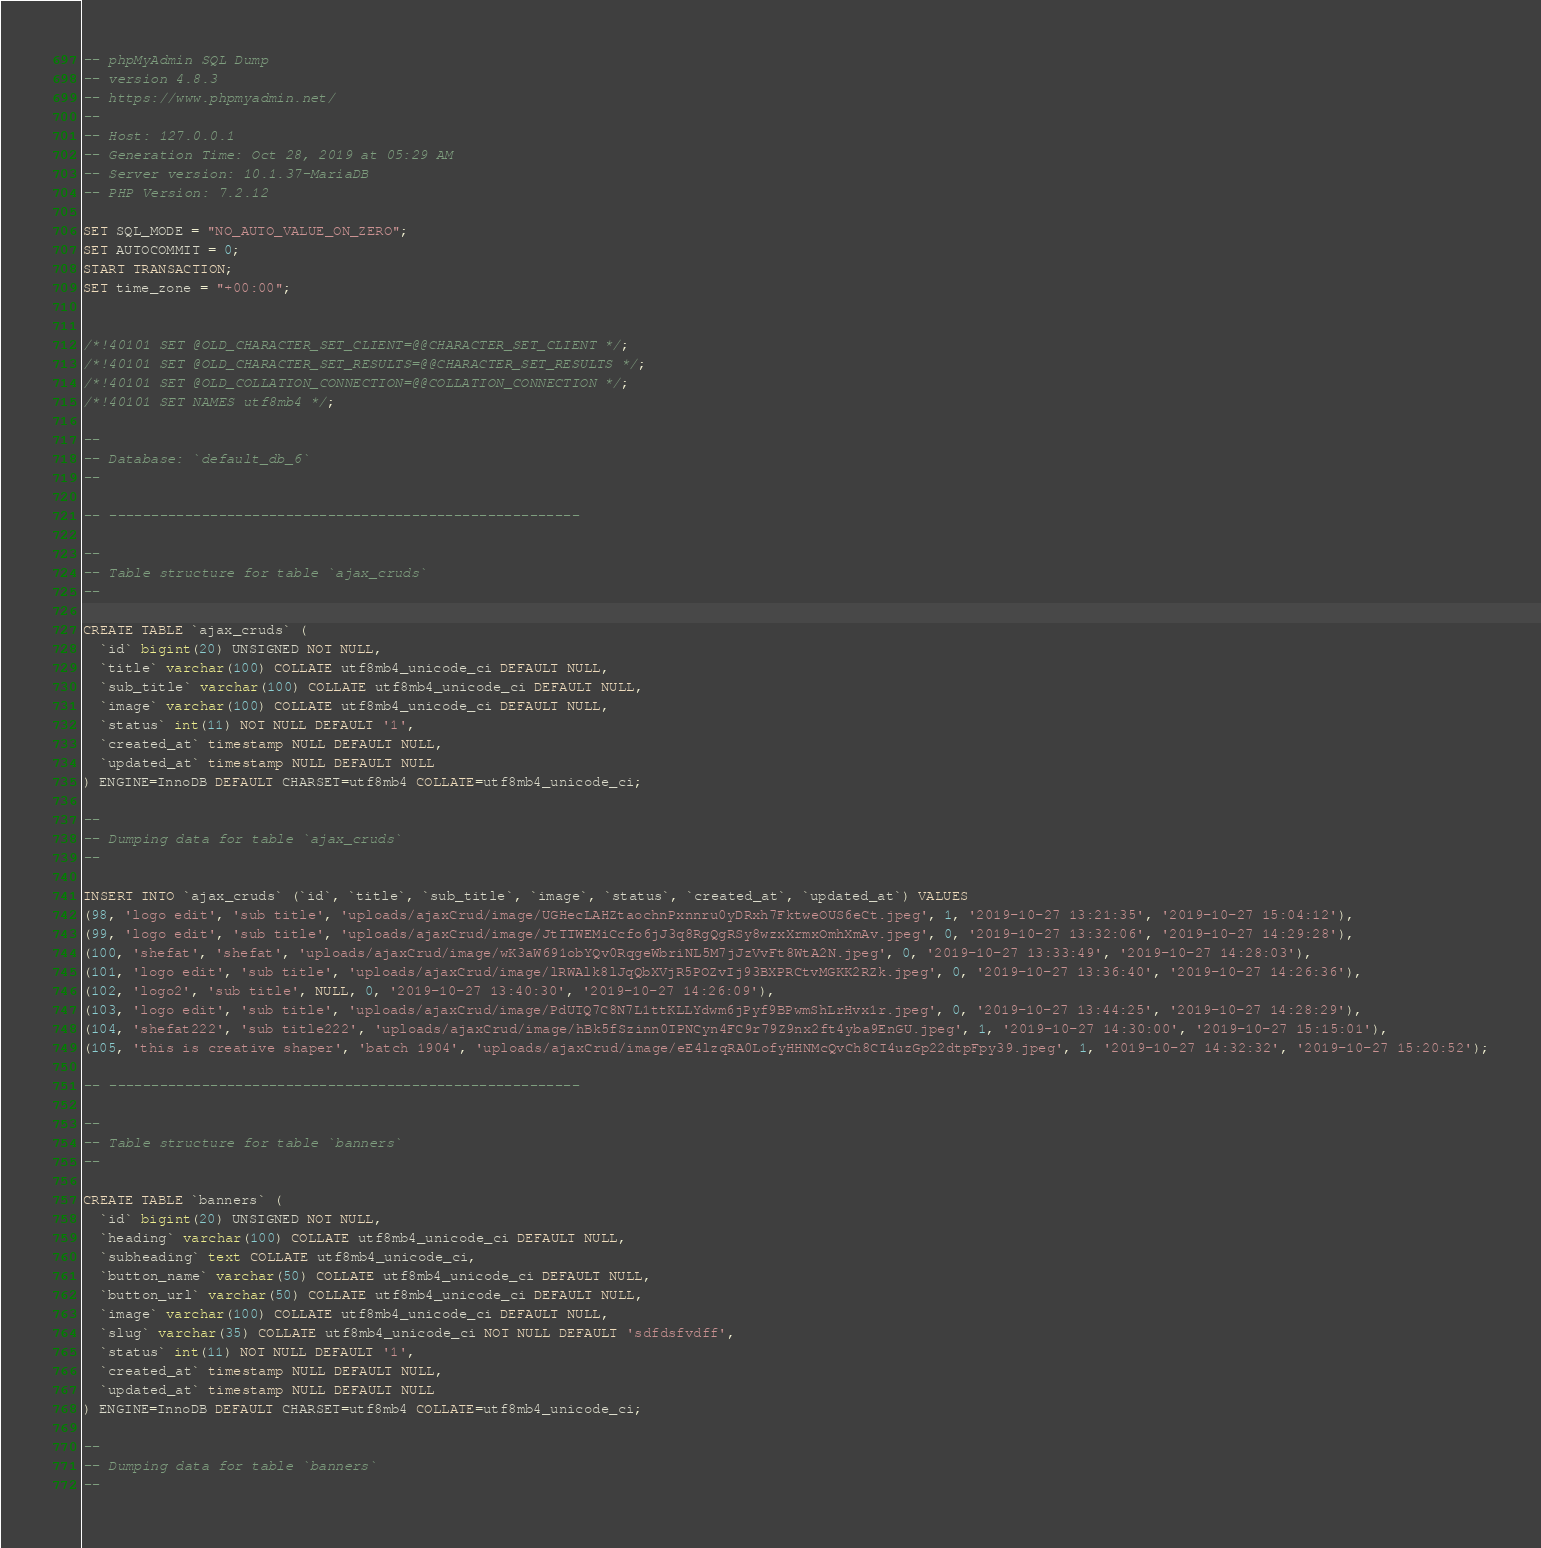Convert code to text. <code><loc_0><loc_0><loc_500><loc_500><_SQL_>-- phpMyAdmin SQL Dump
-- version 4.8.3
-- https://www.phpmyadmin.net/
--
-- Host: 127.0.0.1
-- Generation Time: Oct 28, 2019 at 05:29 AM
-- Server version: 10.1.37-MariaDB
-- PHP Version: 7.2.12

SET SQL_MODE = "NO_AUTO_VALUE_ON_ZERO";
SET AUTOCOMMIT = 0;
START TRANSACTION;
SET time_zone = "+00:00";


/*!40101 SET @OLD_CHARACTER_SET_CLIENT=@@CHARACTER_SET_CLIENT */;
/*!40101 SET @OLD_CHARACTER_SET_RESULTS=@@CHARACTER_SET_RESULTS */;
/*!40101 SET @OLD_COLLATION_CONNECTION=@@COLLATION_CONNECTION */;
/*!40101 SET NAMES utf8mb4 */;

--
-- Database: `default_db_6`
--

-- --------------------------------------------------------

--
-- Table structure for table `ajax_cruds`
--

CREATE TABLE `ajax_cruds` (
  `id` bigint(20) UNSIGNED NOT NULL,
  `title` varchar(100) COLLATE utf8mb4_unicode_ci DEFAULT NULL,
  `sub_title` varchar(100) COLLATE utf8mb4_unicode_ci DEFAULT NULL,
  `image` varchar(100) COLLATE utf8mb4_unicode_ci DEFAULT NULL,
  `status` int(11) NOT NULL DEFAULT '1',
  `created_at` timestamp NULL DEFAULT NULL,
  `updated_at` timestamp NULL DEFAULT NULL
) ENGINE=InnoDB DEFAULT CHARSET=utf8mb4 COLLATE=utf8mb4_unicode_ci;

--
-- Dumping data for table `ajax_cruds`
--

INSERT INTO `ajax_cruds` (`id`, `title`, `sub_title`, `image`, `status`, `created_at`, `updated_at`) VALUES
(98, 'logo edit', 'sub title', 'uploads/ajaxCrud/image/UGHecLAHZtaochnPxnnru0yDRxh7FktweOUS6eCt.jpeg', 1, '2019-10-27 13:21:35', '2019-10-27 15:04:12'),
(99, 'logo edit', 'sub title', 'uploads/ajaxCrud/image/JtTTWEMiCcfo6jJ3q8RgQgRSy8wzxXrmxOmhXmAv.jpeg', 0, '2019-10-27 13:32:06', '2019-10-27 14:29:28'),
(100, 'shefat', 'shefat', 'uploads/ajaxCrud/image/wK3aW691obYQv0RqgeWbriNL5M7jJzVvFt8WtA2N.jpeg', 0, '2019-10-27 13:33:49', '2019-10-27 14:28:03'),
(101, 'logo edit', 'sub title', 'uploads/ajaxCrud/image/lRWAlk8lJqQbXVjR5POZvIj93BXPRCtvMGKK2RZk.jpeg', 0, '2019-10-27 13:36:40', '2019-10-27 14:26:36'),
(102, 'logo2', 'sub title', NULL, 0, '2019-10-27 13:40:30', '2019-10-27 14:26:09'),
(103, 'logo edit', 'sub title', 'uploads/ajaxCrud/image/PdUTQ7C8N7L1ttKLLYdwm6jPyf9BPwmShLrHvx1r.jpeg', 0, '2019-10-27 13:44:25', '2019-10-27 14:28:29'),
(104, 'shefat222', 'sub title222', 'uploads/ajaxCrud/image/hBk5fSzinn0IPNCyn4FC9r79Z9nx2ft4yba9EnGU.jpeg', 1, '2019-10-27 14:30:00', '2019-10-27 15:15:01'),
(105, 'this is creative shaper', 'batch 1904', 'uploads/ajaxCrud/image/eE4lzqRA0LofyHHNMcQvCh8CI4uzGp22dtpFpy39.jpeg', 1, '2019-10-27 14:32:32', '2019-10-27 15:20:52');

-- --------------------------------------------------------

--
-- Table structure for table `banners`
--

CREATE TABLE `banners` (
  `id` bigint(20) UNSIGNED NOT NULL,
  `heading` varchar(100) COLLATE utf8mb4_unicode_ci DEFAULT NULL,
  `subheading` text COLLATE utf8mb4_unicode_ci,
  `button_name` varchar(50) COLLATE utf8mb4_unicode_ci DEFAULT NULL,
  `button_url` varchar(50) COLLATE utf8mb4_unicode_ci DEFAULT NULL,
  `image` varchar(100) COLLATE utf8mb4_unicode_ci DEFAULT NULL,
  `slug` varchar(35) COLLATE utf8mb4_unicode_ci NOT NULL DEFAULT 'sdfdsfvdff',
  `status` int(11) NOT NULL DEFAULT '1',
  `created_at` timestamp NULL DEFAULT NULL,
  `updated_at` timestamp NULL DEFAULT NULL
) ENGINE=InnoDB DEFAULT CHARSET=utf8mb4 COLLATE=utf8mb4_unicode_ci;

--
-- Dumping data for table `banners`
--
</code> 